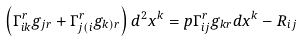<formula> <loc_0><loc_0><loc_500><loc_500>\left ( \Gamma _ { i k } ^ { r } g _ { j r } + \Gamma _ { j ( i } ^ { r } g _ { k ) r } \right ) d ^ { 2 } x ^ { k } = p \Gamma _ { i j } ^ { r } g _ { k r } d x ^ { k } - R _ { i j }</formula> 